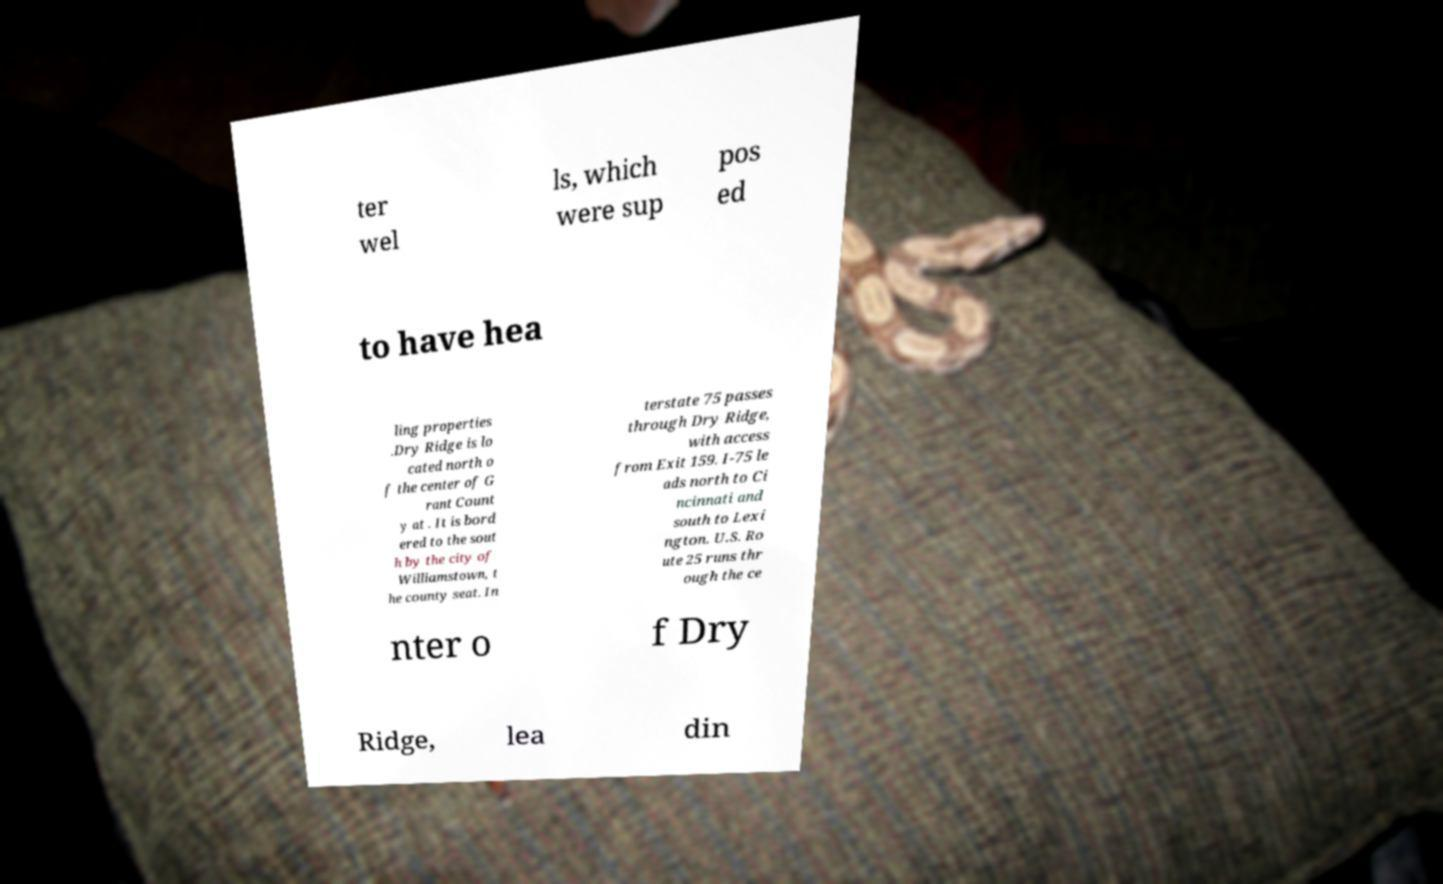Could you extract and type out the text from this image? ter wel ls, which were sup pos ed to have hea ling properties .Dry Ridge is lo cated north o f the center of G rant Count y at . It is bord ered to the sout h by the city of Williamstown, t he county seat. In terstate 75 passes through Dry Ridge, with access from Exit 159. I-75 le ads north to Ci ncinnati and south to Lexi ngton. U.S. Ro ute 25 runs thr ough the ce nter o f Dry Ridge, lea din 